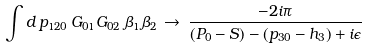Convert formula to latex. <formula><loc_0><loc_0><loc_500><loc_500>\int d \, p _ { 1 2 0 } \, G _ { 0 1 } G _ { 0 2 } \, \beta _ { 1 } \beta _ { 2 } \, \to \, { \frac { - 2 i \pi } { ( P _ { 0 } - S ) - ( p _ { 3 0 } - h _ { 3 } ) + i \epsilon } }</formula> 